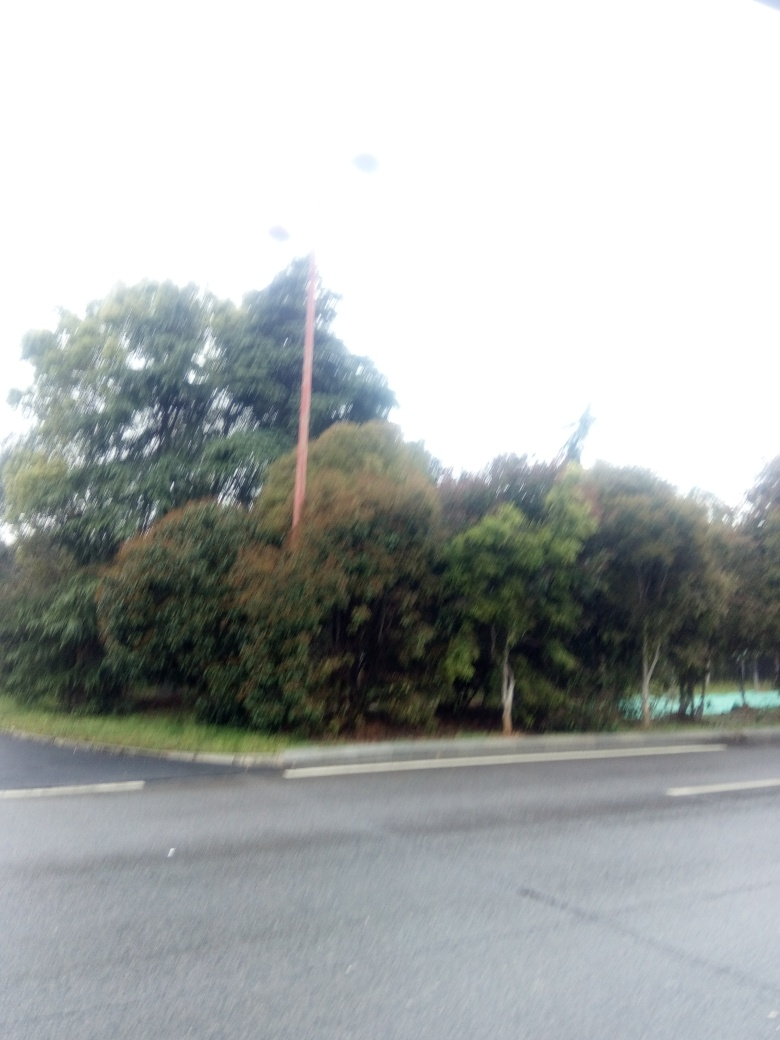Is there any potential artistic merit to the current state of the image, despite its technical imperfections? Artistically, the overexposed nature of the image could be seen as a stylistic choice, evoking a sense of ambiguity or dreaminess. It may also emphasize certain moods or themes, such as depicting a memory, a bright future, or a scene with a mystical or ethereal quality. 